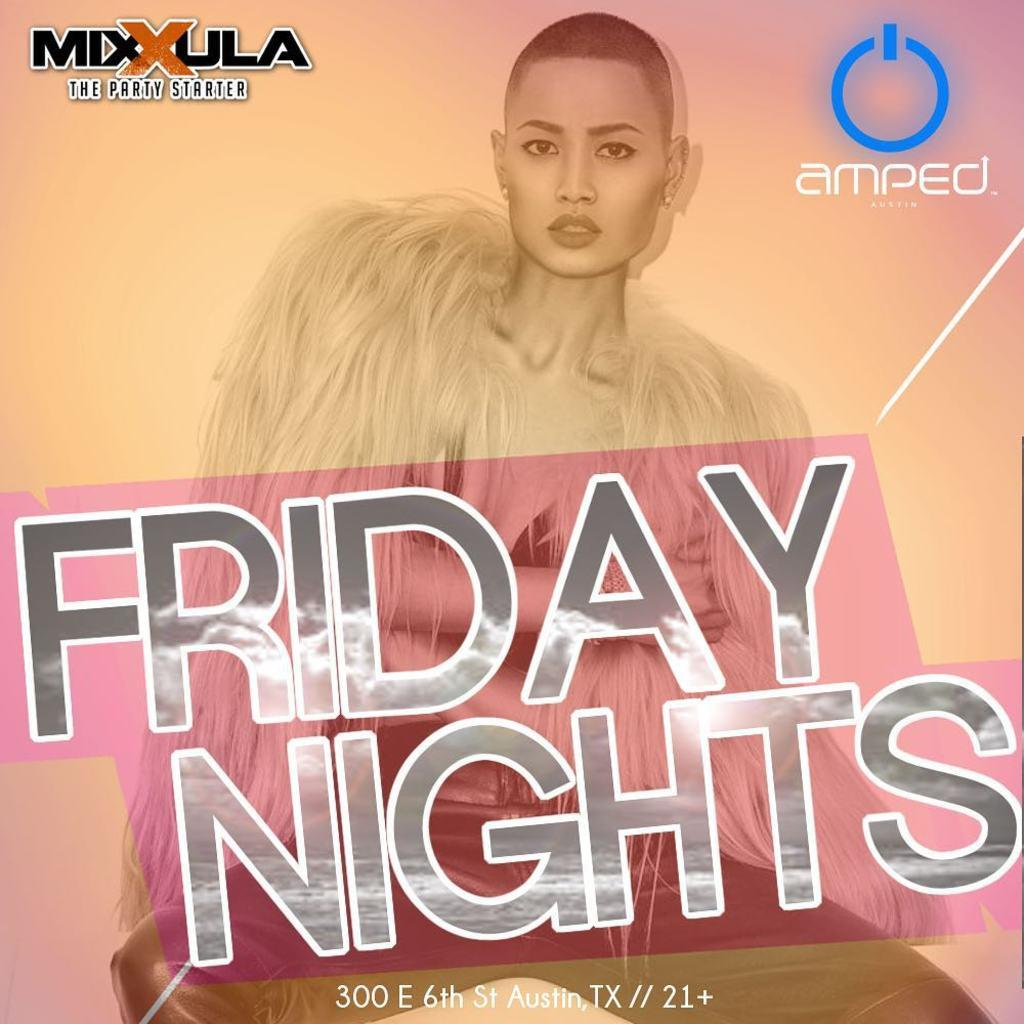What is the main subject of the image? There is a person in the image. Can you describe any additional elements in the image? Yes, there is text on the image. What type of drum is being played in the image? There is no drum present in the image; it only features a person and text. What crime is being committed in the image? There is no crime depicted in the image; it only features a person and text. 